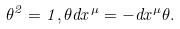<formula> <loc_0><loc_0><loc_500><loc_500>\theta ^ { 2 } = 1 , \theta d x ^ { \mu } = - d x ^ { \mu } \theta .</formula> 